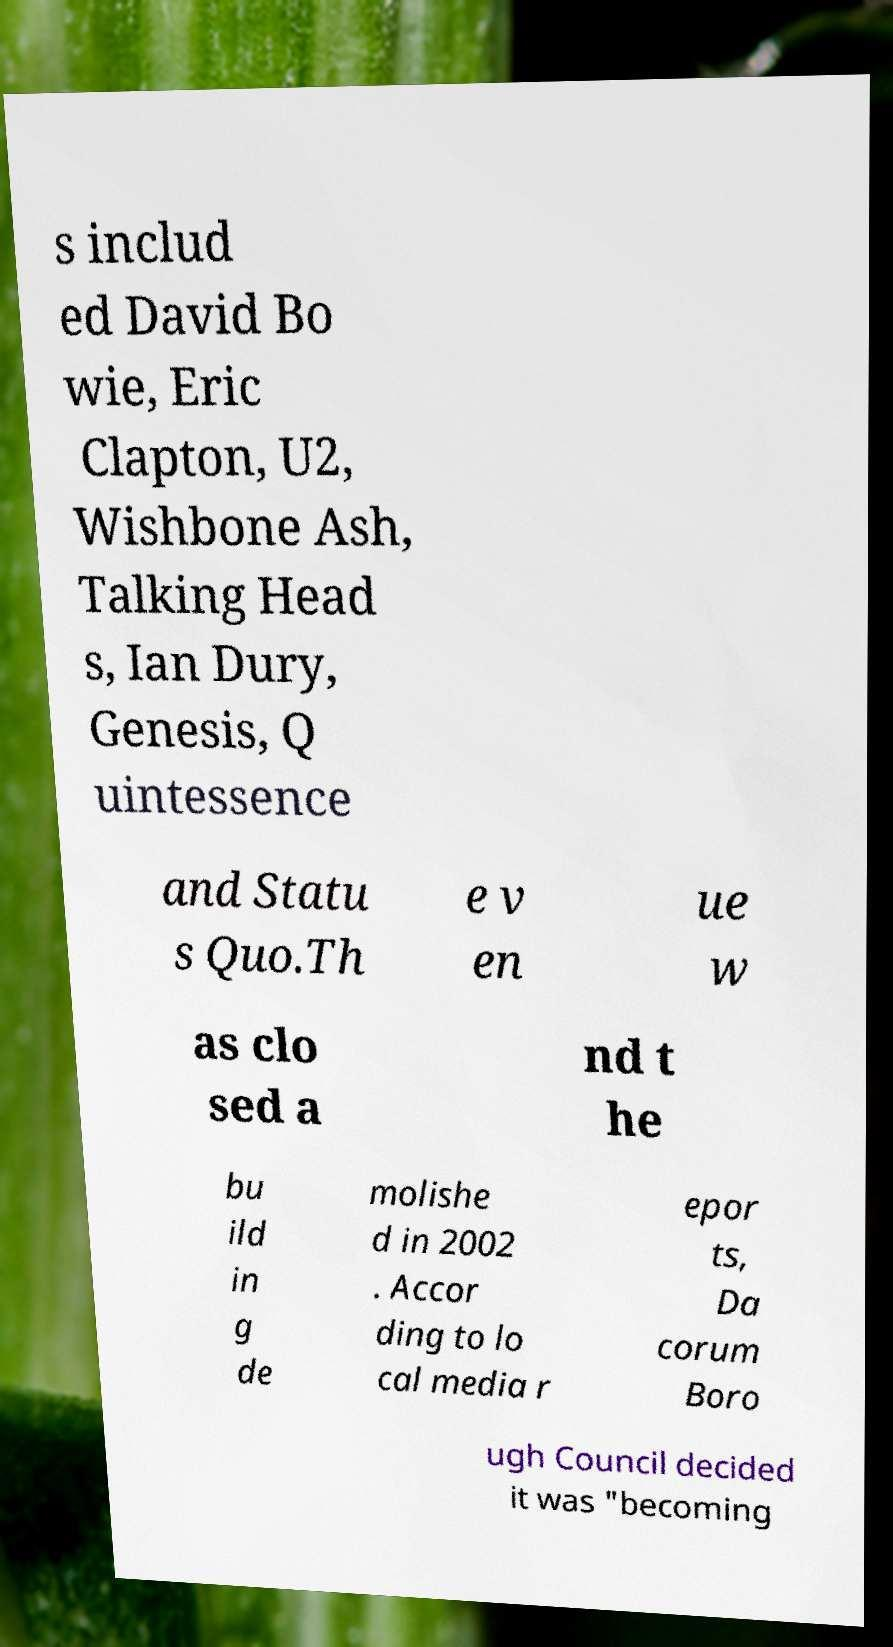Please identify and transcribe the text found in this image. s includ ed David Bo wie, Eric Clapton, U2, Wishbone Ash, Talking Head s, Ian Dury, Genesis, Q uintessence and Statu s Quo.Th e v en ue w as clo sed a nd t he bu ild in g de molishe d in 2002 . Accor ding to lo cal media r epor ts, Da corum Boro ugh Council decided it was "becoming 